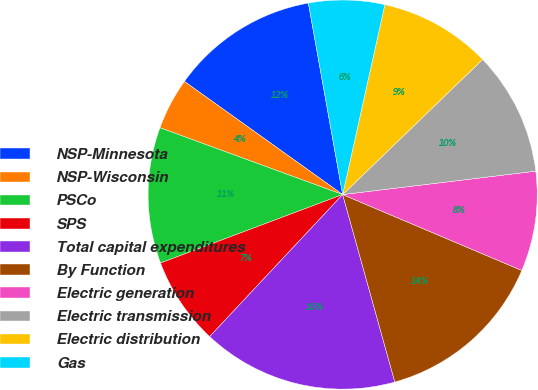Convert chart. <chart><loc_0><loc_0><loc_500><loc_500><pie_chart><fcel>NSP-Minnesota<fcel>NSP-Wisconsin<fcel>PSCo<fcel>SPS<fcel>Total capital expenditures<fcel>By Function<fcel>Electric generation<fcel>Electric transmission<fcel>Electric distribution<fcel>Gas<nl><fcel>12.3%<fcel>4.3%<fcel>11.3%<fcel>7.3%<fcel>16.3%<fcel>14.3%<fcel>8.3%<fcel>10.3%<fcel>9.3%<fcel>6.3%<nl></chart> 